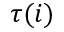Convert formula to latex. <formula><loc_0><loc_0><loc_500><loc_500>\tau ( i )</formula> 